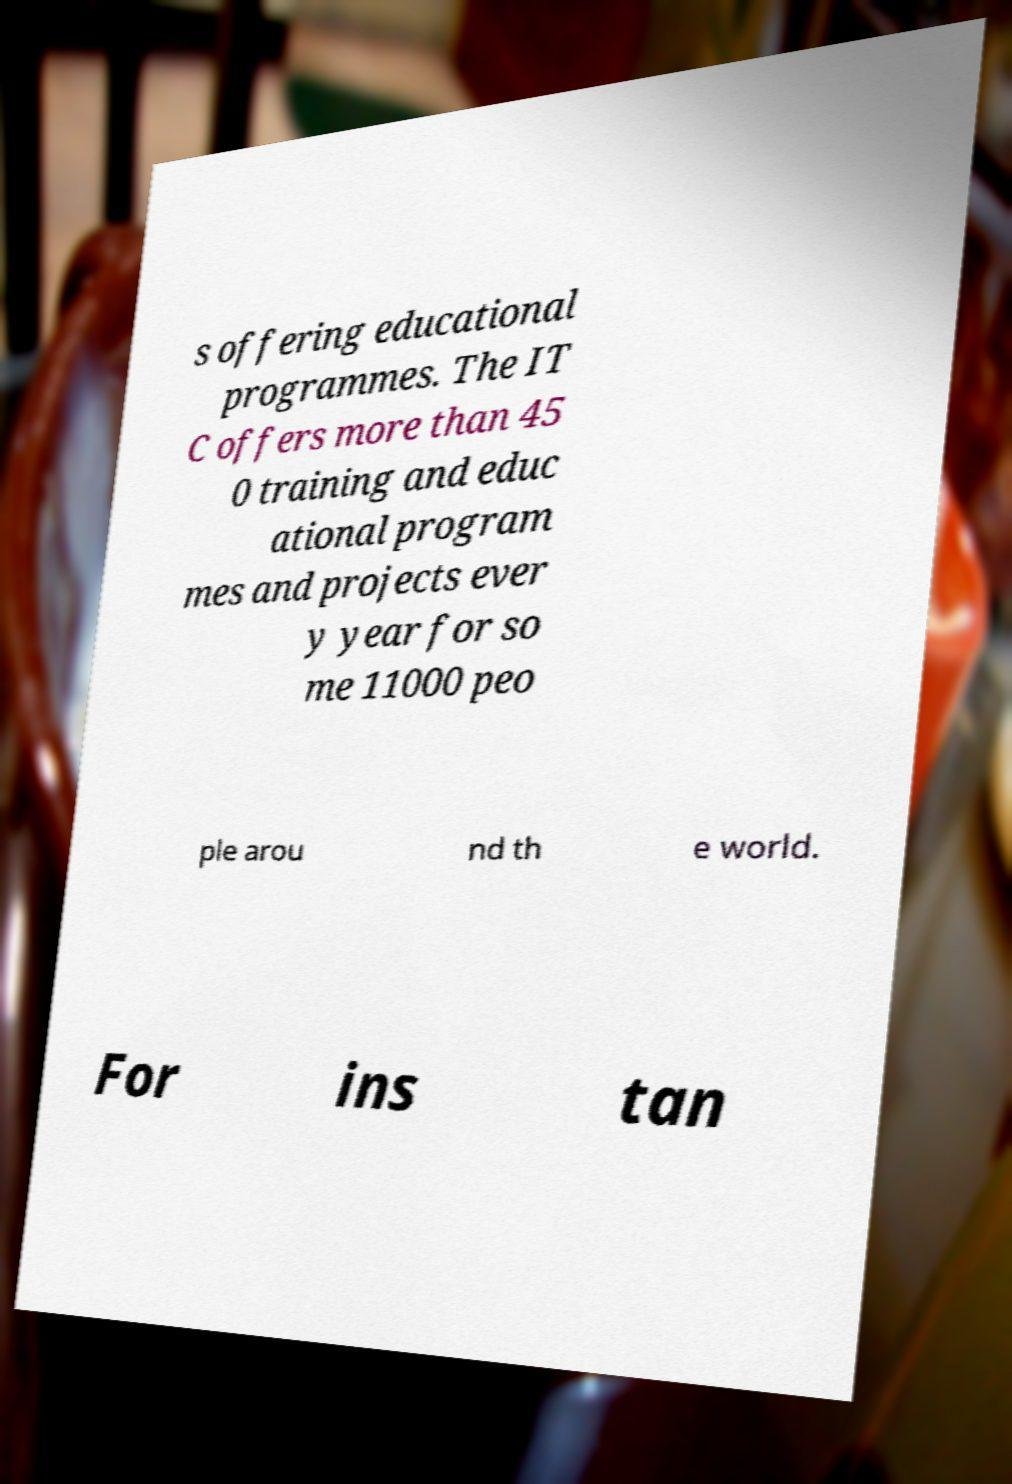What messages or text are displayed in this image? I need them in a readable, typed format. s offering educational programmes. The IT C offers more than 45 0 training and educ ational program mes and projects ever y year for so me 11000 peo ple arou nd th e world. For ins tan 